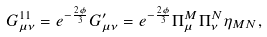Convert formula to latex. <formula><loc_0><loc_0><loc_500><loc_500>G _ { \mu \nu } ^ { 1 1 } = e ^ { - \frac { 2 \phi } { 3 } } G _ { \mu \nu } ^ { \prime } = e ^ { - \frac { 2 \phi } { 3 } } \Pi _ { \mu } ^ { M } \Pi _ { \nu } ^ { N } \eta _ { M N } ,</formula> 